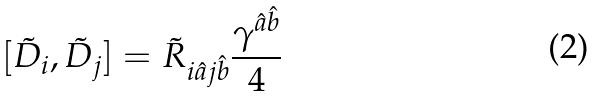Convert formula to latex. <formula><loc_0><loc_0><loc_500><loc_500>[ \tilde { D } _ { i } , \tilde { D } _ { j } ] = \tilde { R } _ { i \hat { a } j \hat { b } } \frac { \gamma ^ { \hat { a } \hat { b } } } { 4 }</formula> 